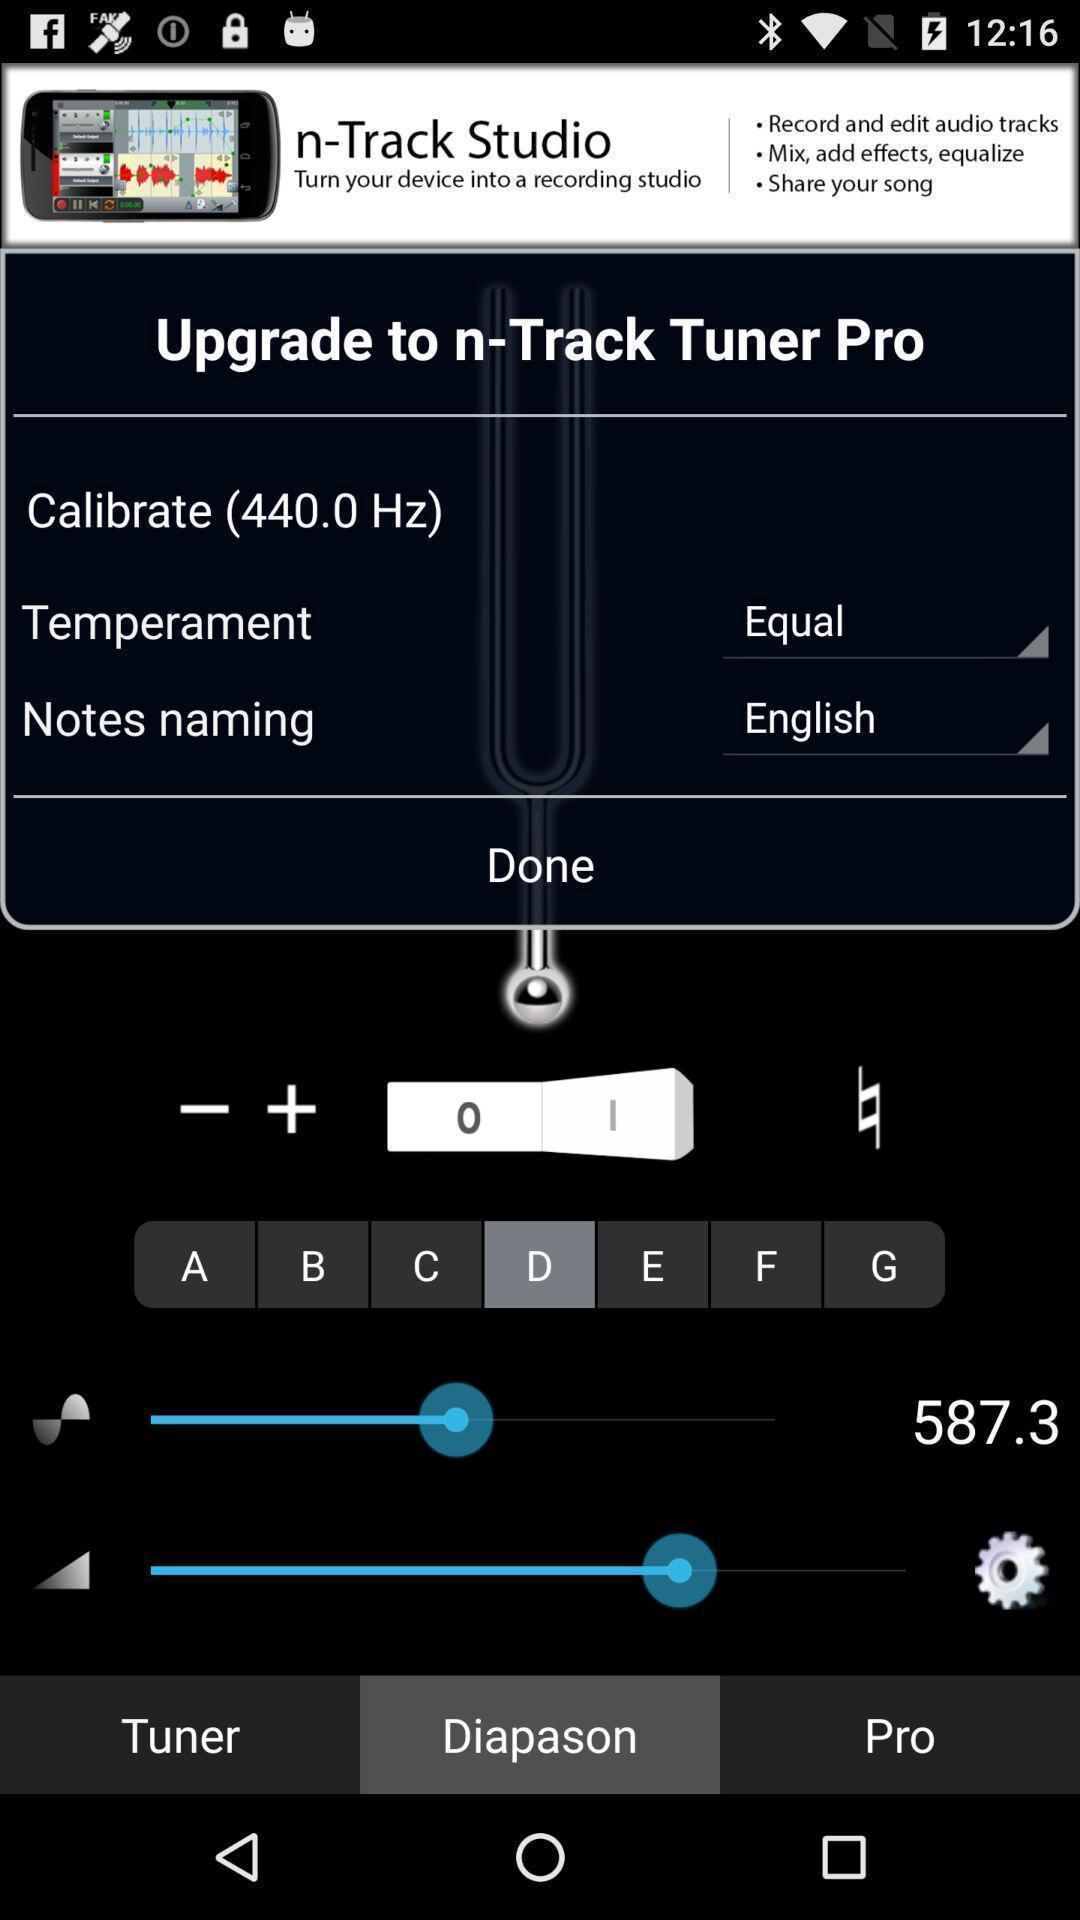Tell me about the visual elements in this screen capture. Page showing the multiple option in audio tuner app. 